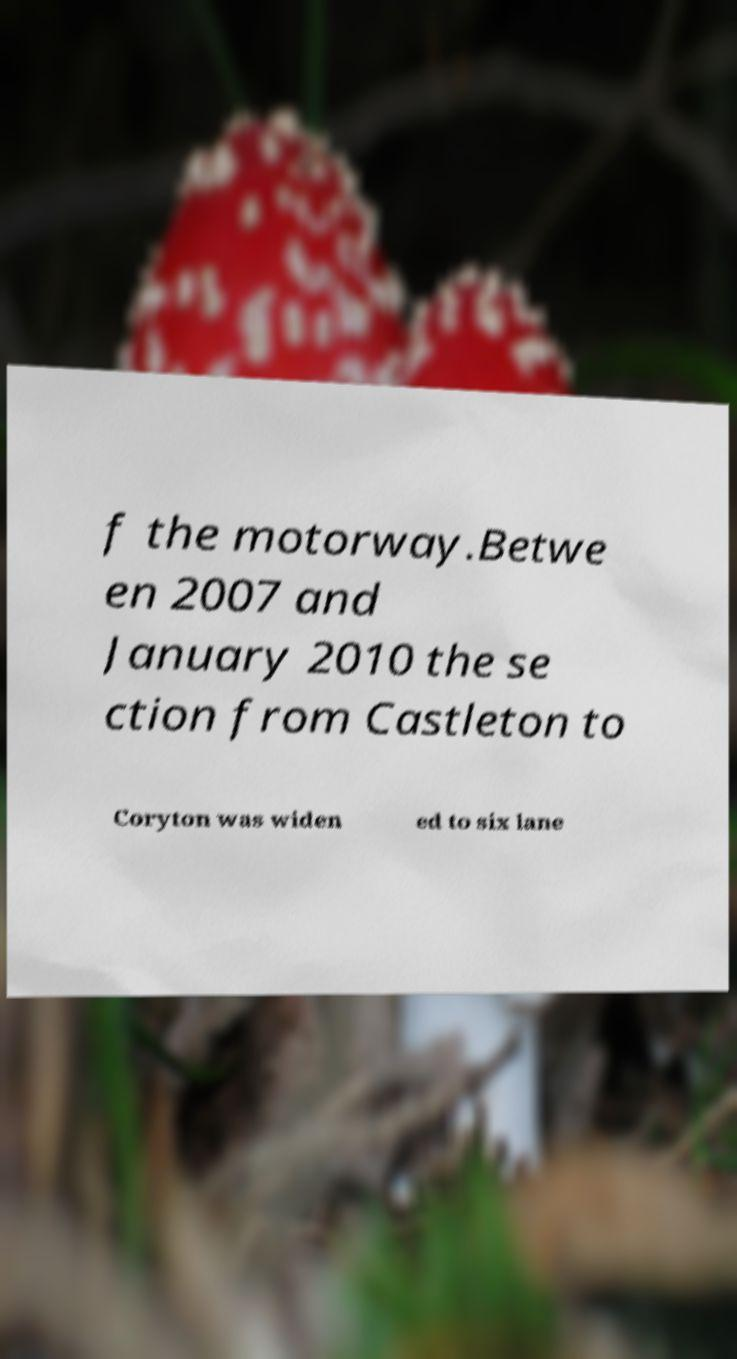There's text embedded in this image that I need extracted. Can you transcribe it verbatim? f the motorway.Betwe en 2007 and January 2010 the se ction from Castleton to Coryton was widen ed to six lane 